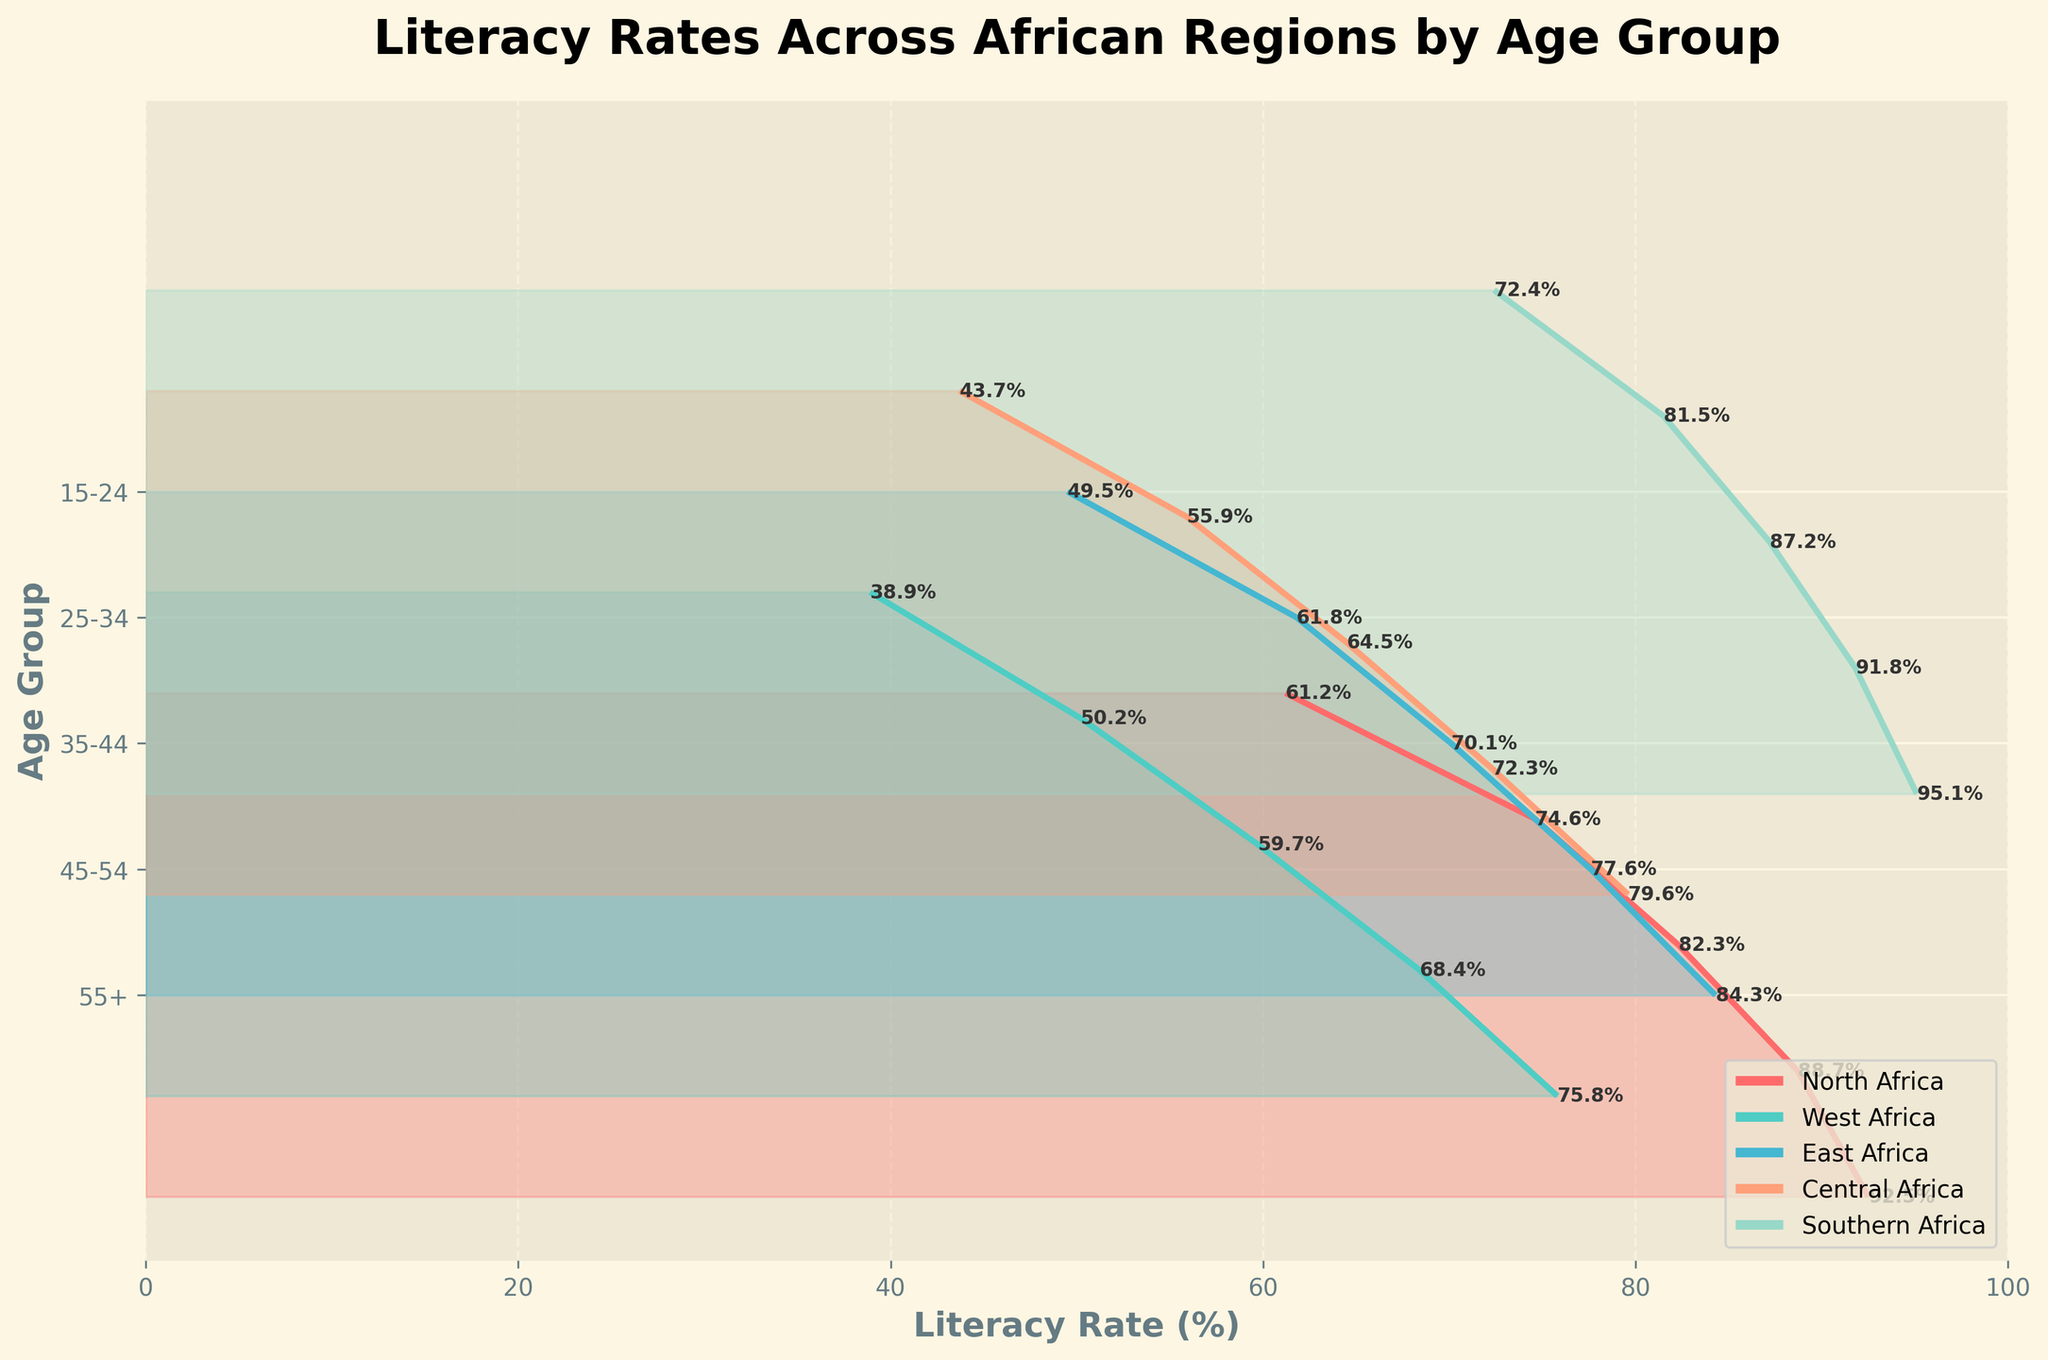What is the title of the figure? The title is often located at the top center of the figure and usually written in bold text. In this case, it specifies what the plot is about.
Answer: Literacy Rates Across African Regions by Age Group Which region has the highest literacy rate for the age group 15-24? Look for the age group 15-24 on the y-axis and follow the plot line to see which region's literacy rate is the highest. According to the figure, Southern Africa's literacy rate is the highest for this age group.
Answer: Southern Africa What is the literacy rate for the age group 55+ in West Africa? Locate the age group 55+ on the y-axis, then find the corresponding value of the literacy rate for West Africa along the x-axis.
Answer: 38.9% How does the literacy rate change with age in North Africa? Observe the trend of the plot lines for North Africa across different age groups from 15-24 to 55+. Notice how the line descends as the age group increases, indicating decreasing literacy rates with increasing age.
Answer: It decreases with age Compare the literacy rates of the 25-34 age group between East Africa and Central Africa. Which one is higher? Find the age group 25-34 on the y-axis, then compare the literacy rates of East and Central Africa. The rate is higher for East Africa.
Answer: East Africa Which region shows the steepest decline in literacy rates from the age group 15-24 to 55+? Observe the slope of the plot lines from the age group 15-24 to 55+. The region with the steepest decline will show the largest dip in literacy rates. West Africa's line shows the steepest decline.
Answer: West Africa What is the average literacy rate for East Africa across all age groups? Sum the literacy rates for all age groups in East Africa and divide by the number of age groups (5). (84.3 + 77.6 + 70.1 + 61.8 + 49.5) / 5 = 68.66
Answer: 68.66% Which two regions have the closest literacy rates for the age group 35-44? Look at the literacy rates for the 35-44 age group and compare the values among all regions to find the closest rates. Central Africa and East Africa have the closest rates at 64.5% and 70.1%, respectively.
Answer: Central Africa and East Africa In Southern Africa, how many percentage points does the literacy rate decrease from the age group 15-24 to 55+? Subtract the literacy rate of the age group 55+ from the literacy rate of the age group 15-24 in Southern Africa. 95.1% - 72.4% = 22.7
Answer: 22.7 